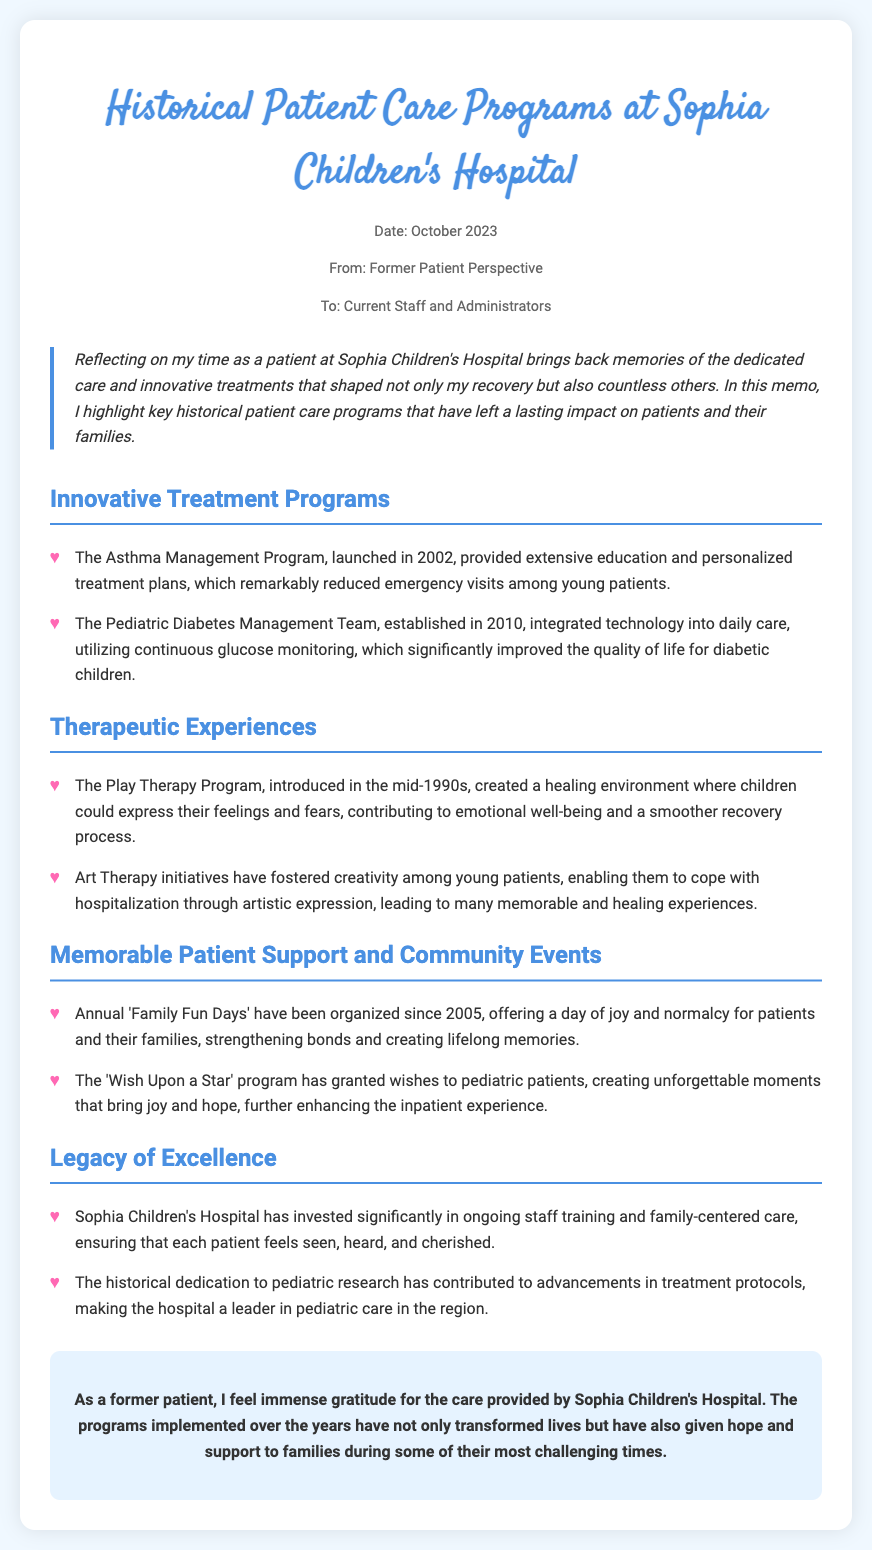what year was the Asthma Management Program launched? The Asthma Management Program was launched in 2002 as stated in the document.
Answer: 2002 who established the Pediatric Diabetes Management Team? The document states that the Pediatric Diabetes Management Team was established in 2010, but it does not specify who established it.
Answer: Not specified what program was introduced in the mid-1990s? The Play Therapy Program was introduced in the mid-1990s according to the document.
Answer: The Play Therapy Program how many years have 'Family Fun Days' been organized as of 2023? The document states that 'Family Fun Days' have been organized since 2005, so to find the total years up to 2023, we calculate 2023 - 2005 = 18 years.
Answer: 18 what type of therapy fosters creativity among young patients? According to the document, Art Therapy initiatives foster creativity among young patients.
Answer: Art Therapy what is the purpose of the 'Wish Upon a Star' program? The document states that the purpose of the 'Wish Upon a Star' program is to grant wishes to pediatric patients, creating unforgettable moments.
Answer: To grant wishes how does the hospital ensure each patient feels seen and heard? The document indicates that the hospital invests significantly in ongoing staff training and family-centered care to ensure this.
Answer: Ongoing staff training and family-centered care what color is used for the section headings in the document? The document describes that the section headings are colored #4a90e2.
Answer: #4a90e2 what does the conclusion of the memo express gratitude for? The conclusion of the memo expresses gratitude for the care provided by Sophia Children's Hospital.
Answer: The care provided by Sophia Children's Hospital 